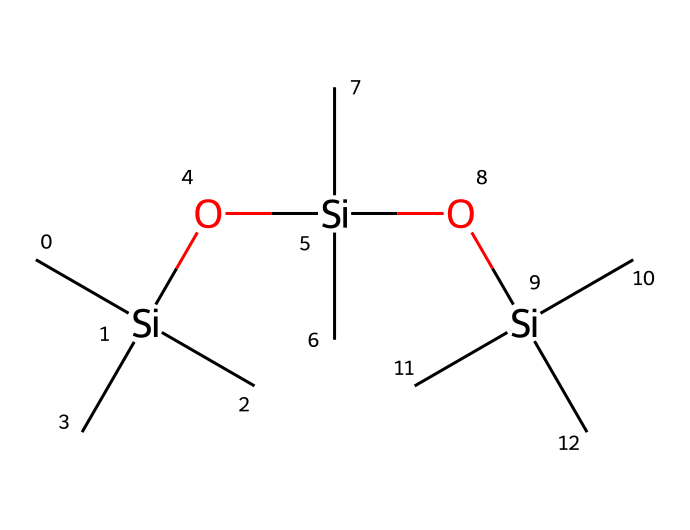how many silicon atoms are present in this compound? The SMILES representation lists three silicon atoms represented by 'Si'. By counting the 'Si' within the structure, we can confirm there are three occurrences.
Answer: three what is the primary functional group in this chemical structure? The presence of 'O' indicates the functional group. In this case, the compound has multiple silicon-oxygen linkages (Si-O), which are characteristic of siloxane functional groups, as seen in organosilicon compounds.
Answer: siloxane how many carbon atoms are part of this compound? Each 'C' in the SMILES string represents a carbon atom. There are nine 'C' atoms present when counted.
Answer: nine what type of bonding is predominant in this organosilicon compound? The primary bonding type in this chemical is covalent, which is observed between silicon and oxygen, as well as between silicon and carbon atoms. This is typical for organosilicon compounds.
Answer: covalent how does the structure contribute to its waterproofing properties? The arrangement of silicon and oxygen atoms creates a highly hydrophobic surface, which means water is repelled effectively. This hydrophobicity enhances the waterproofing capability of the compound, making it suitable for protecting folklore artifacts.
Answer: hydrophobic what is the molecular formula derived from this SMILES representation? The number of each atom type can be counted from the SMILES: C9H30Si3O3. Counting confirms nine carbon (C), thirty hydrogen (H), three silicon (Si), and three oxygen (O) atoms, leading to the molecular formula C9H30Si3O3.
Answer: C9H30Si3O3 